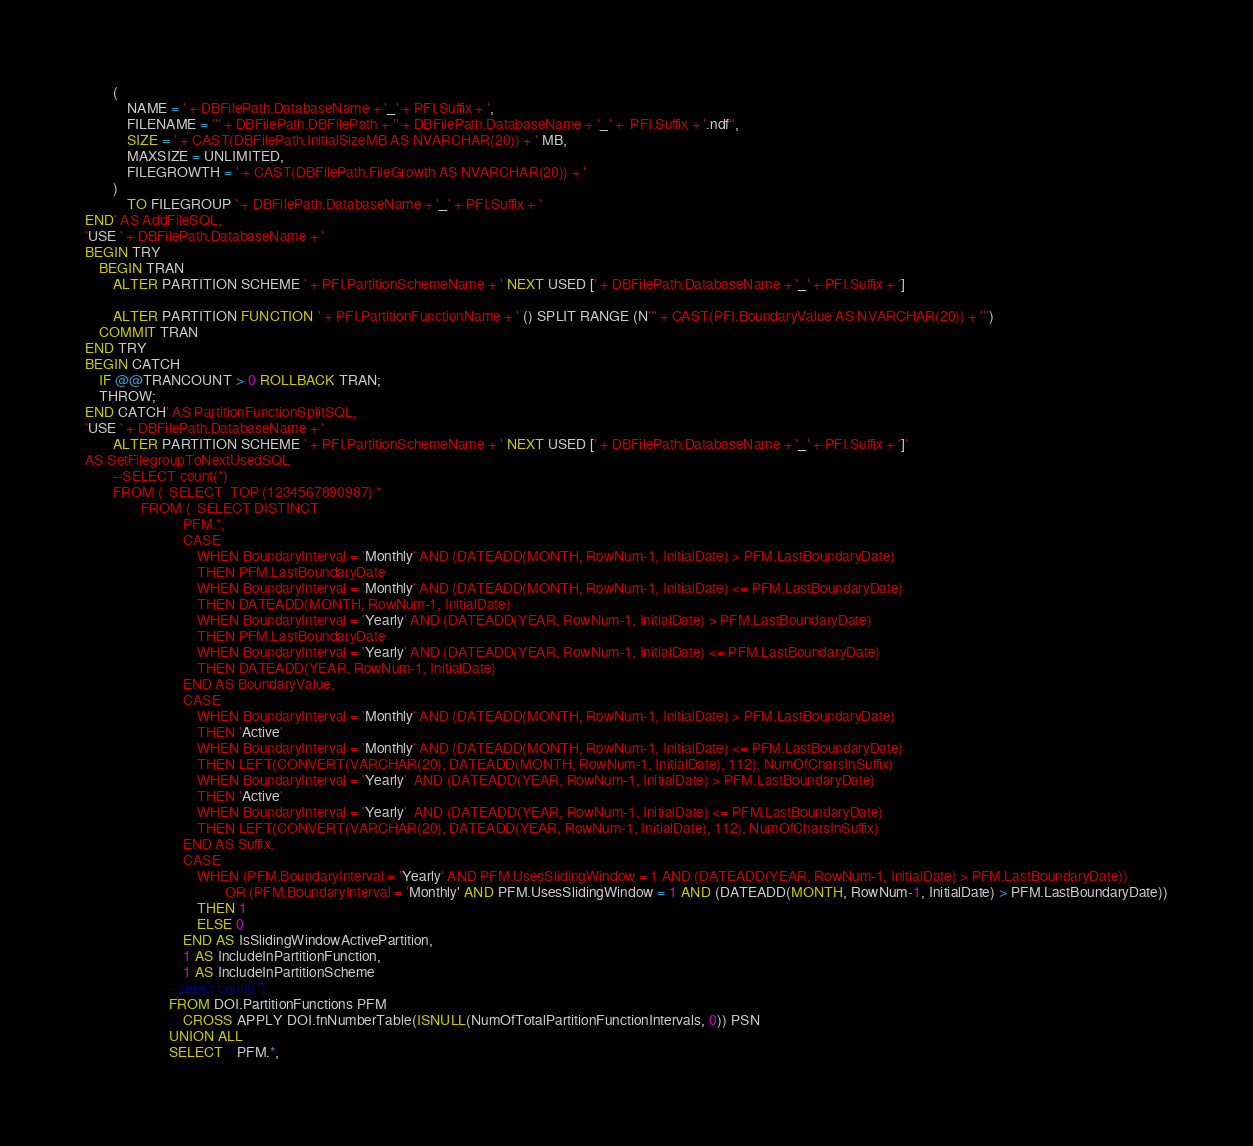Convert code to text. <code><loc_0><loc_0><loc_500><loc_500><_SQL_>		(
    		NAME = ' + DBFilePath.DatabaseName + '_' + PFI.Suffix + ', 
    		FILENAME = ''' + DBFilePath.DBFilePath + '' + DBFilePath.DatabaseName + '_' +  PFI.Suffix + '.ndf'', 
			SIZE = ' + CAST(DBFilePath.InitialSizeMB AS NVARCHAR(20)) + ' MB, 
			MAXSIZE = UNLIMITED, 
			FILEGROWTH = ' + CAST(DBFilePath.FileGrowth AS NVARCHAR(20)) + '
		) 
			TO FILEGROUP ' + DBFilePath.DatabaseName + '_' + PFI.Suffix + '
END' AS AddFileSQL,
'USE ' + DBFilePath.DatabaseName + '
BEGIN TRY
	BEGIN TRAN
		ALTER PARTITION SCHEME ' + PFI.PartitionSchemeName + ' NEXT USED [' + DBFilePath.DatabaseName + '_' + PFI.Suffix + ']

		ALTER PARTITION FUNCTION ' + PFI.PartitionFunctionName + ' () SPLIT RANGE (N''' + CAST(PFI.BoundaryValue AS NVARCHAR(20)) + ''')
	COMMIT TRAN
END TRY
BEGIN CATCH
	IF @@TRANCOUNT > 0 ROLLBACK TRAN;
	THROW;
END CATCH' AS PartitionFunctionSplitSQL,
'USE ' + DBFilePath.DatabaseName + '
		ALTER PARTITION SCHEME ' + PFI.PartitionSchemeName + ' NEXT USED [' + DBFilePath.DatabaseName + '_' + PFI.Suffix + ']' 
AS SetFilegroupToNextUsedSQL
        --SELECT count(*)
        FROM (  SELECT	TOP (1234567890987) *
                FROM (	SELECT DISTINCT
			                PFM.*,
							CASE  
								WHEN BoundaryInterval = 'Monthly' AND (DATEADD(MONTH, RowNum-1, InitialDate) > PFM.LastBoundaryDate) 
								THEN PFM.LastBoundaryDate
								WHEN BoundaryInterval = 'Monthly' AND (DATEADD(MONTH, RowNum-1, InitialDate) <= PFM.LastBoundaryDate) 
								THEN DATEADD(MONTH, RowNum-1, InitialDate)
								WHEN BoundaryInterval = 'Yearly' AND (DATEADD(YEAR, RowNum-1, InitialDate) > PFM.LastBoundaryDate)
								THEN PFM.LastBoundaryDate
								WHEN BoundaryInterval = 'Yearly' AND (DATEADD(YEAR, RowNum-1, InitialDate) <= PFM.LastBoundaryDate)
								THEN DATEADD(YEAR, RowNum-1, InitialDate)
							END AS BoundaryValue,
							CASE 
								WHEN BoundaryInterval = 'Monthly' AND (DATEADD(MONTH, RowNum-1, InitialDate) > PFM.LastBoundaryDate) 
								THEN 'Active'
								WHEN BoundaryInterval = 'Monthly' AND (DATEADD(MONTH, RowNum-1, InitialDate) <= PFM.LastBoundaryDate) 
								THEN LEFT(CONVERT(VARCHAR(20), DATEADD(MONTH, RowNum-1, InitialDate), 112), NumOfCharsInSuffix) 
								WHEN BoundaryInterval = 'Yearly'  AND (DATEADD(YEAR, RowNum-1, InitialDate) > PFM.LastBoundaryDate)
								THEN 'Active'
								WHEN BoundaryInterval = 'Yearly'  AND (DATEADD(YEAR, RowNum-1, InitialDate) <= PFM.LastBoundaryDate)
								THEN LEFT(CONVERT(VARCHAR(20), DATEADD(YEAR, RowNum-1, InitialDate), 112), NumOfCharsInSuffix) 
							END AS Suffix,
							CASE 
								WHEN (PFM.BoundaryInterval = 'Yearly' AND PFM.UsesSlidingWindow = 1 AND (DATEADD(YEAR, RowNum-1, InitialDate) > PFM.LastBoundaryDate))
										OR (PFM.BoundaryInterval = 'Monthly' AND PFM.UsesSlidingWindow = 1 AND (DATEADD(MONTH, RowNum-1, InitialDate) > PFM.LastBoundaryDate))
								THEN 1
								ELSE 0
							END AS IsSlidingWindowActivePartition,
							1 AS IncludeInPartitionFunction,
							1 AS IncludeInPartitionScheme
						--select count(*)
						FROM DOI.PartitionFunctions PFM
							CROSS APPLY DOI.fnNumberTable(ISNULL(NumOfTotalPartitionFunctionIntervals, 0)) PSN
						UNION ALL
						SELECT	PFM.*,</code> 